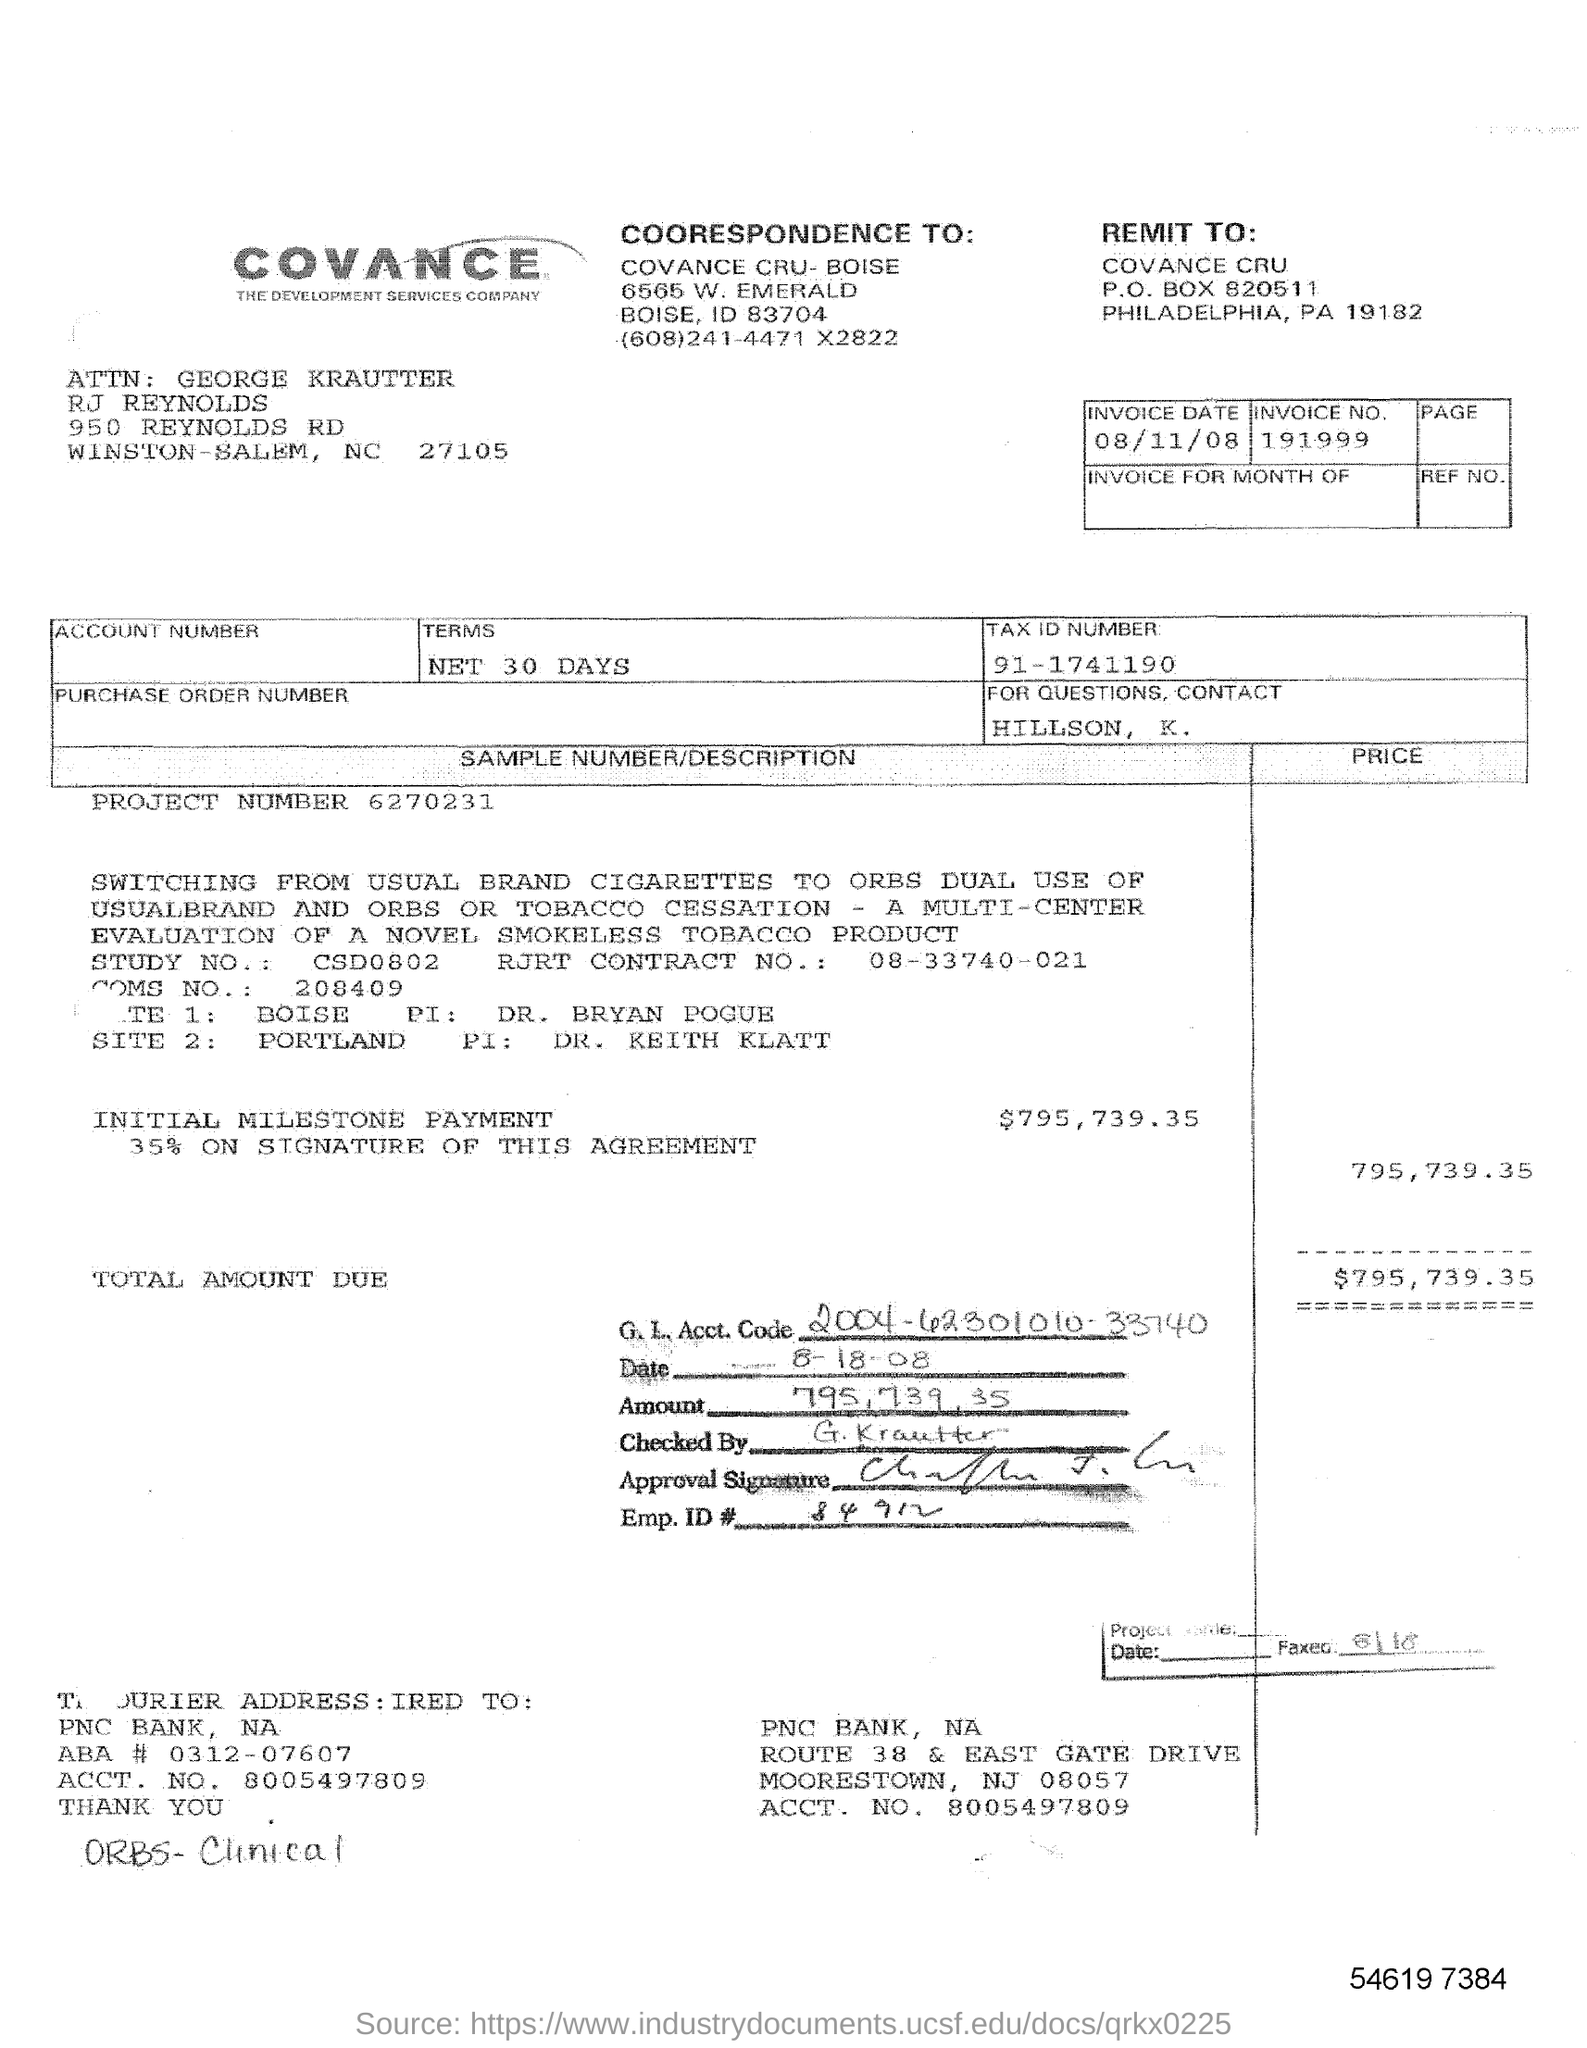What is the invoice number?
Your answer should be very brief. 191999. What is the date on the bill invoice
Your answer should be compact. 08/11/08. Whom to contact, if there are any queries?
Provide a succinct answer. HILLSON, K. How much is the initial milestone payment?
Offer a terse response. $795,739.35. 